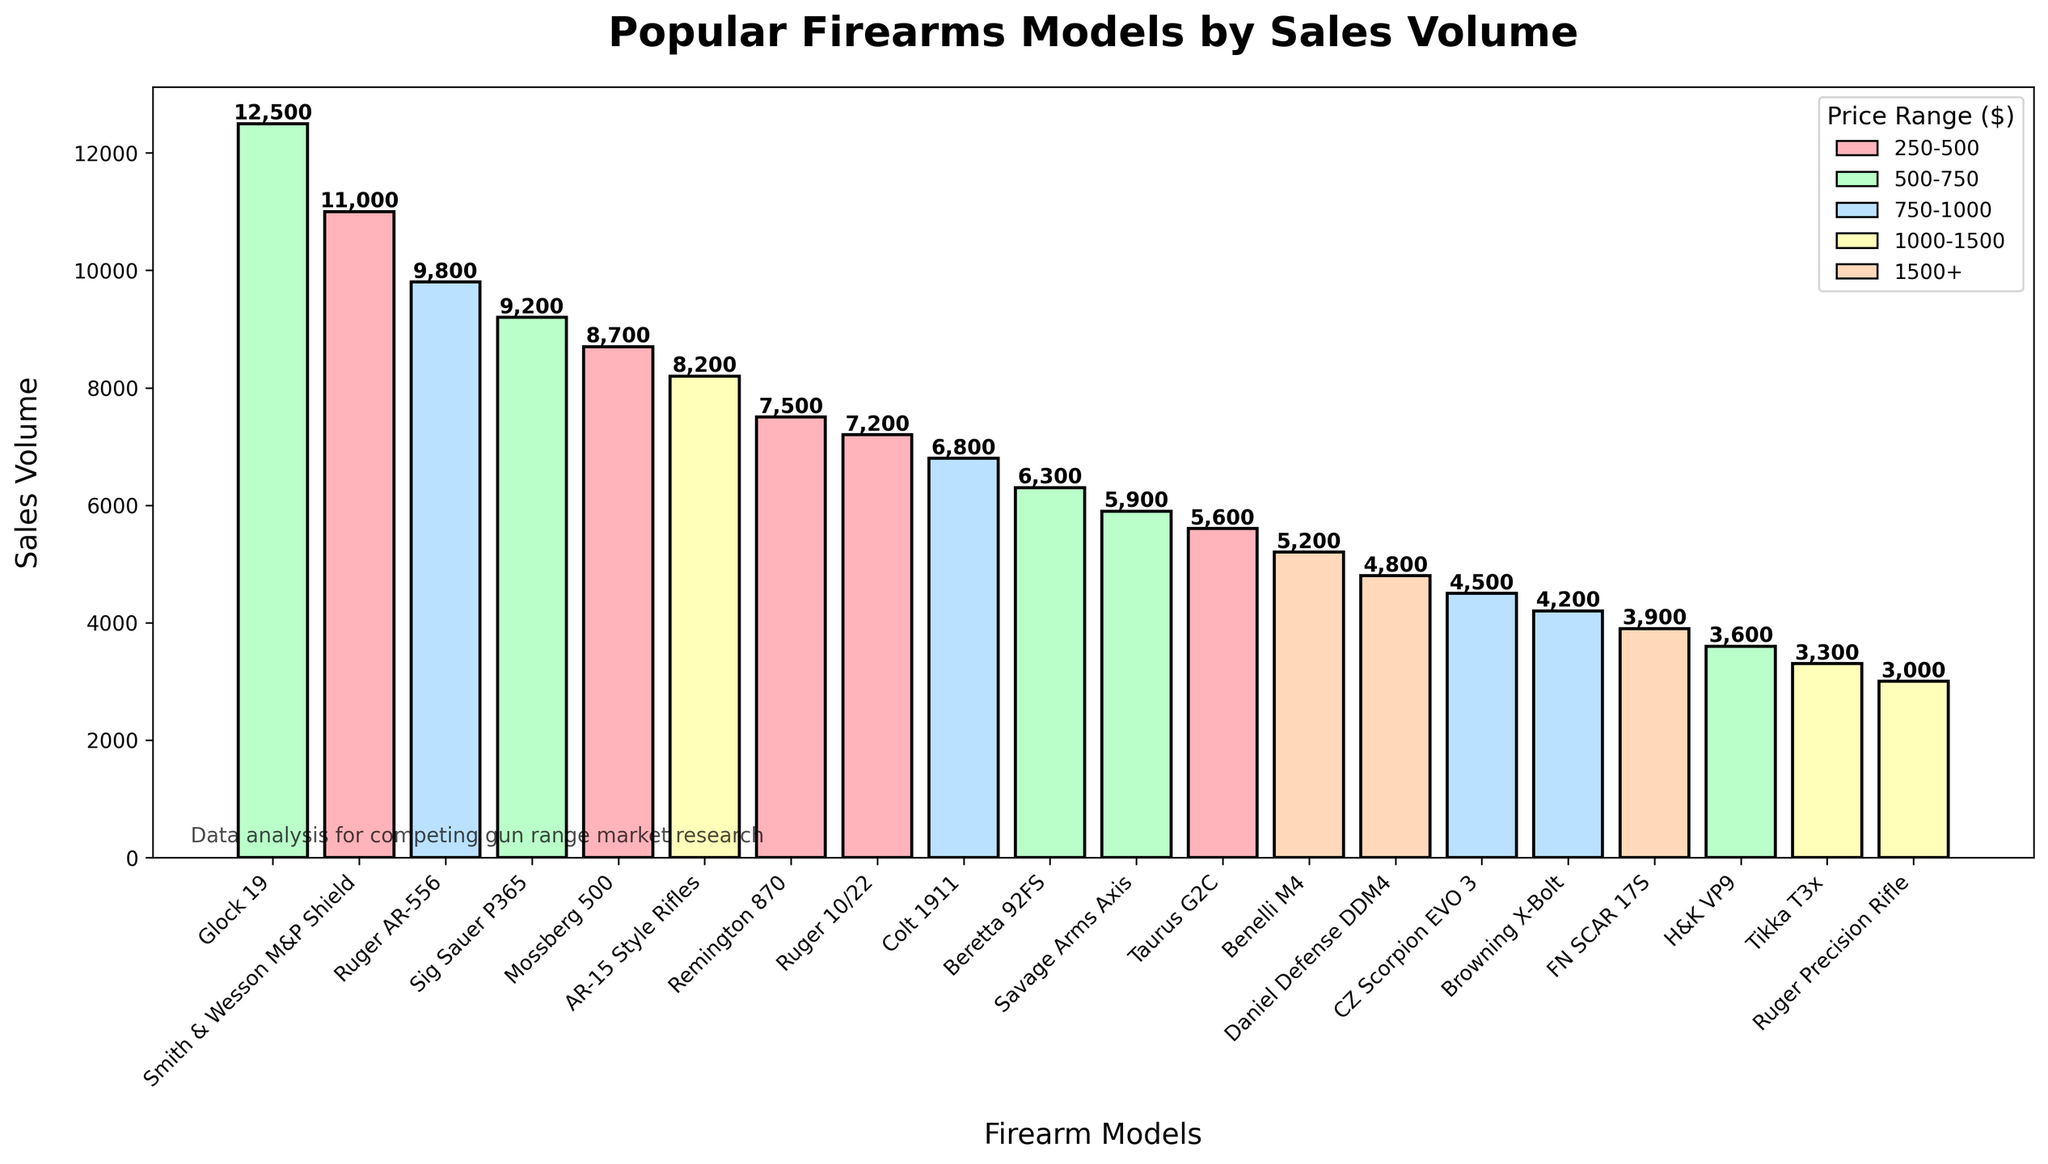Which firearm model has the highest sales volume? The bar representing the Glock 19 is the tallest, indicating that it has the highest sales volume.
Answer: Glock 19 Which price range has the highest number of firearm models shown in the chart? By looking at the color coding of the bars, the 250-500 price range has the most models as it appears most frequently.
Answer: 250-500 What is the total sales volume of all models in the 500-750 price range? Models in the 500-750 range include Glock 19, Sig Sauer P365, Beretta 92FS, Savage Arms Axis, and H&K VP9. Their sales volumes are 12500, 9200, 6300, 5900, and 3600 respectively. Summing them up gives 12500 + 9200 + 6300 + 5900 + 3600 = 37500.
Answer: 37500 Which firearm model has higher sales volume: Ruger AR-556 or Colt 1911? Comparing the heights of the bars, Ruger AR-556 has a higher volume than Colt 1911. Ruger AR-556 has a volume of 9800 and Colt 1911 has 6800.
Answer: Ruger AR-556 What is the average sales volume for models in the 1500+ price range? Models in the 1500+ range include Benelli M4, Daniel Defense DDM4, and FN SCAR 17S with volumes of 5200, 4800, and 3900 respectively. Their total volume is 5200 + 4800 + 3900 = 13900. Dividing by 3 gives 13900 / 3 ≈ 4633.33.
Answer: 4633.33 Which model in the 250-500 price range has the second highest sales volume? Looking at the bars within the 250-500 color, Smith & Wesson M&P Shield has the highest, followed by Mossberg 500.
Answer: Mossberg 500 Which price range does the firearm model with the second highest sales volume fall under? The second highest sales volume is for Smith & Wesson M&P Shield which is in the 250-500 price range.
Answer: 250-500 How does the sales volume of AR-15 Style Rifles compare to Tikka T3x? AR-15 Style Rifles have a significantly higher sales volume than Tikka T3x. AR-15 Style Rifles have 8200, while Tikka T3x has 3300.
Answer: AR-15 Style Rifles have higher sales What is the cumulative sales volume of all models in the 1000-1500 price range? Models in the 1000-1500 range are AR-15 Style Rifles, Tikka T3x, and Ruger Precision Rifle. Their sales volumes are 8200, 3300, and 3000 respectively. Summing them up gives 8200 + 3300 + 3000 = 14500.
Answer: 14500 